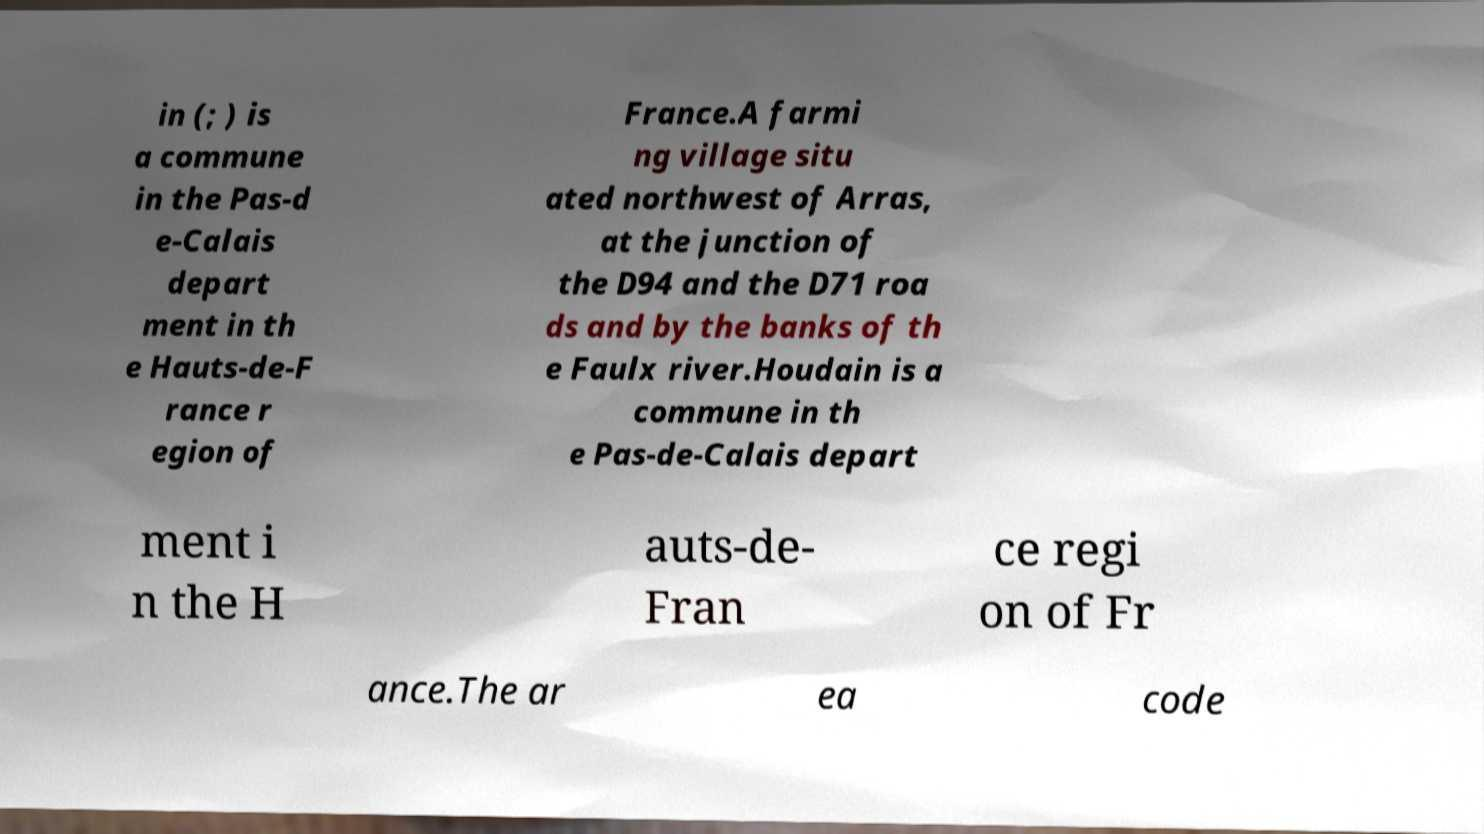Please read and relay the text visible in this image. What does it say? in (; ) is a commune in the Pas-d e-Calais depart ment in th e Hauts-de-F rance r egion of France.A farmi ng village situ ated northwest of Arras, at the junction of the D94 and the D71 roa ds and by the banks of th e Faulx river.Houdain is a commune in th e Pas-de-Calais depart ment i n the H auts-de- Fran ce regi on of Fr ance.The ar ea code 